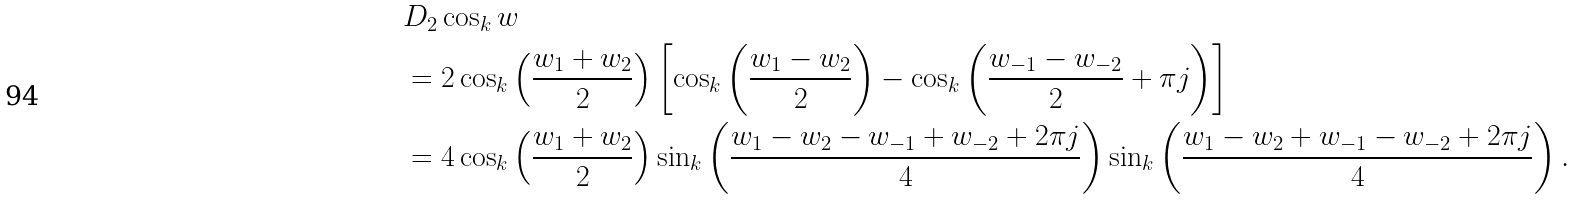Convert formula to latex. <formula><loc_0><loc_0><loc_500><loc_500>& D _ { 2 } \cos _ { k } w \\ & = 2 \cos _ { k } \left ( \frac { w _ { 1 } + w _ { 2 } } 2 \right ) \left [ \cos _ { k } \left ( \frac { w _ { 1 } - w _ { 2 } } 2 \right ) - \cos _ { k } \left ( \frac { w _ { - 1 } - w _ { - 2 } } 2 + \pi j \right ) \right ] \\ & = 4 \cos _ { k } \left ( \frac { w _ { 1 } + w _ { 2 } } 2 \right ) \sin _ { k } \left ( \frac { w _ { 1 } - w _ { 2 } - w _ { - 1 } + w _ { - 2 } + 2 \pi j } { 4 } \right ) \sin _ { k } \left ( \frac { w _ { 1 } - w _ { 2 } + w _ { - 1 } - w _ { - 2 } + 2 \pi j } { 4 } \right ) .</formula> 